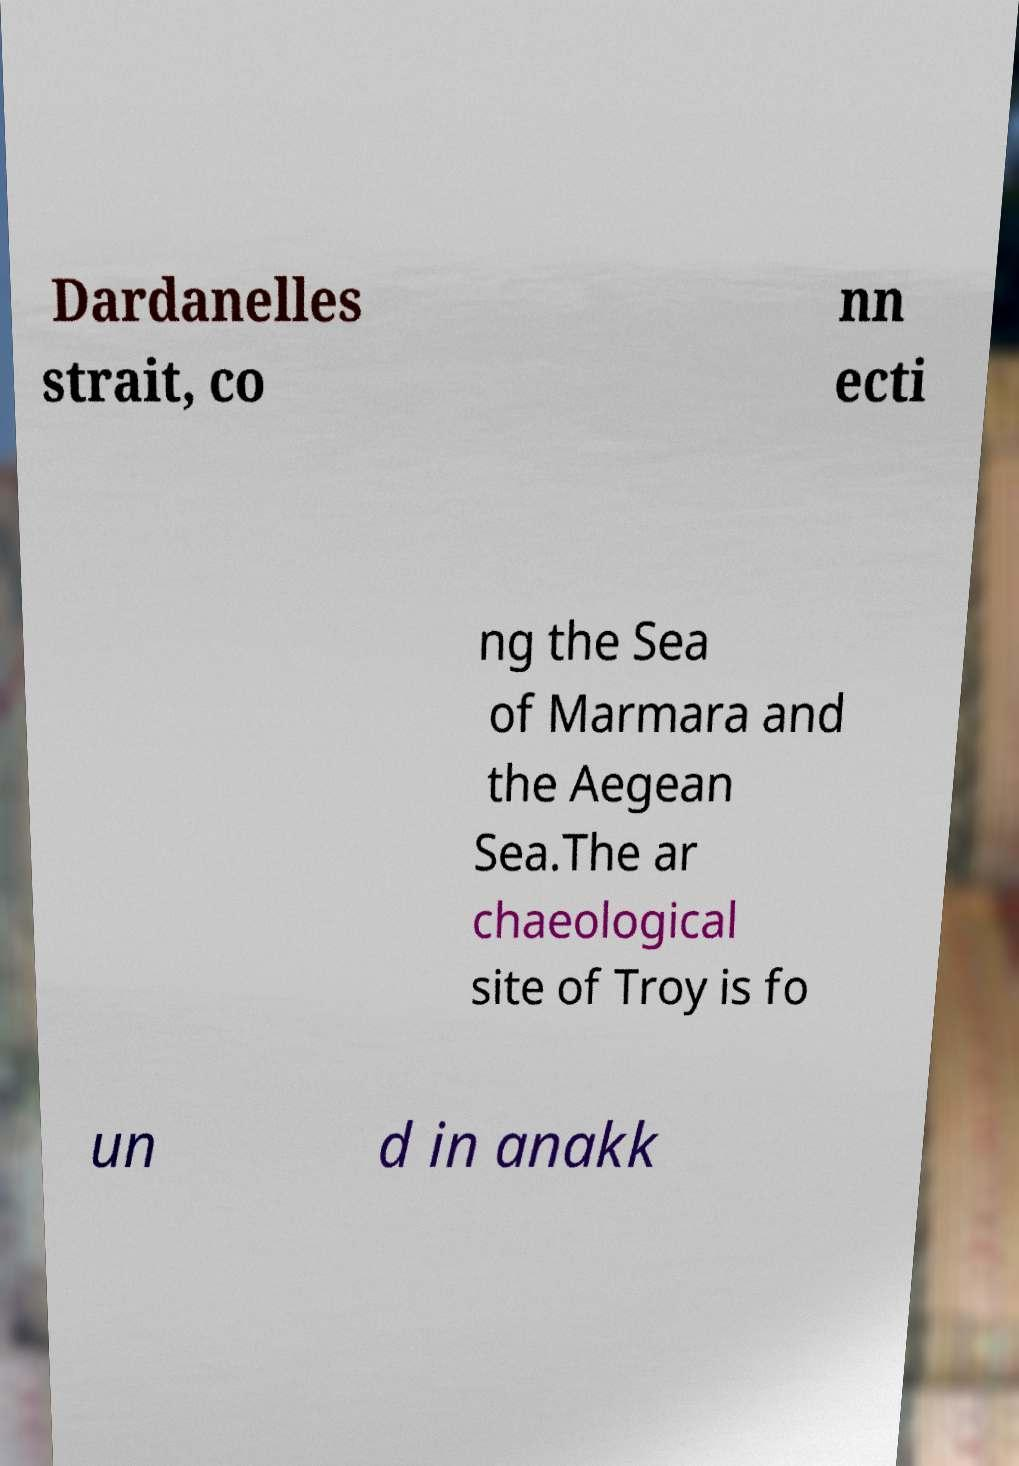Could you extract and type out the text from this image? Dardanelles strait, co nn ecti ng the Sea of Marmara and the Aegean Sea.The ar chaeological site of Troy is fo un d in anakk 